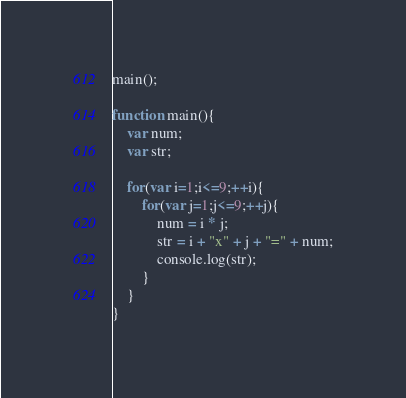<code> <loc_0><loc_0><loc_500><loc_500><_JavaScript_>main();

function main(){
    var num;
    var str;
    
    for(var i=1;i<=9;++i){
        for(var j=1;j<=9;++j){
            num = i * j;
            str = i + "x" + j + "=" + num;
            console.log(str);
        }
    }
}</code> 